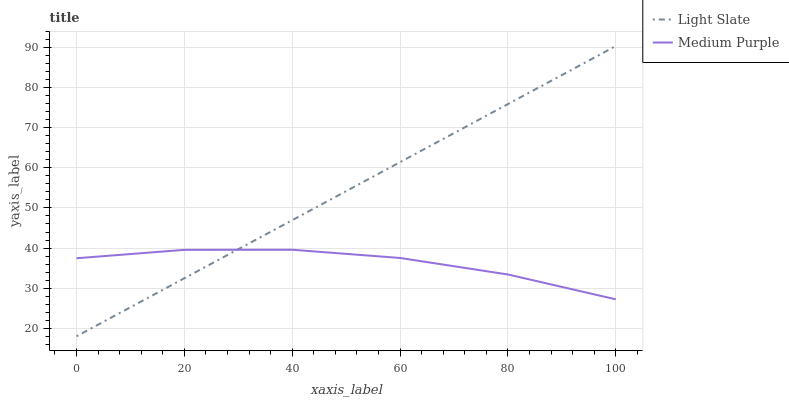Does Medium Purple have the minimum area under the curve?
Answer yes or no. Yes. Does Light Slate have the maximum area under the curve?
Answer yes or no. Yes. Does Medium Purple have the maximum area under the curve?
Answer yes or no. No. Is Light Slate the smoothest?
Answer yes or no. Yes. Is Medium Purple the roughest?
Answer yes or no. Yes. Is Medium Purple the smoothest?
Answer yes or no. No. Does Light Slate have the lowest value?
Answer yes or no. Yes. Does Medium Purple have the lowest value?
Answer yes or no. No. Does Light Slate have the highest value?
Answer yes or no. Yes. Does Medium Purple have the highest value?
Answer yes or no. No. Does Medium Purple intersect Light Slate?
Answer yes or no. Yes. Is Medium Purple less than Light Slate?
Answer yes or no. No. Is Medium Purple greater than Light Slate?
Answer yes or no. No. 